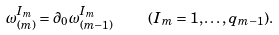<formula> <loc_0><loc_0><loc_500><loc_500>\omega _ { ( m ) } ^ { I _ { m } } = \partial _ { 0 } \omega _ { ( m - 1 ) } ^ { I _ { m } } \quad ( I _ { m } = 1 , \dots , q _ { m - 1 } ) .</formula> 